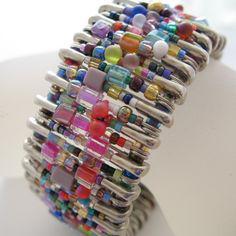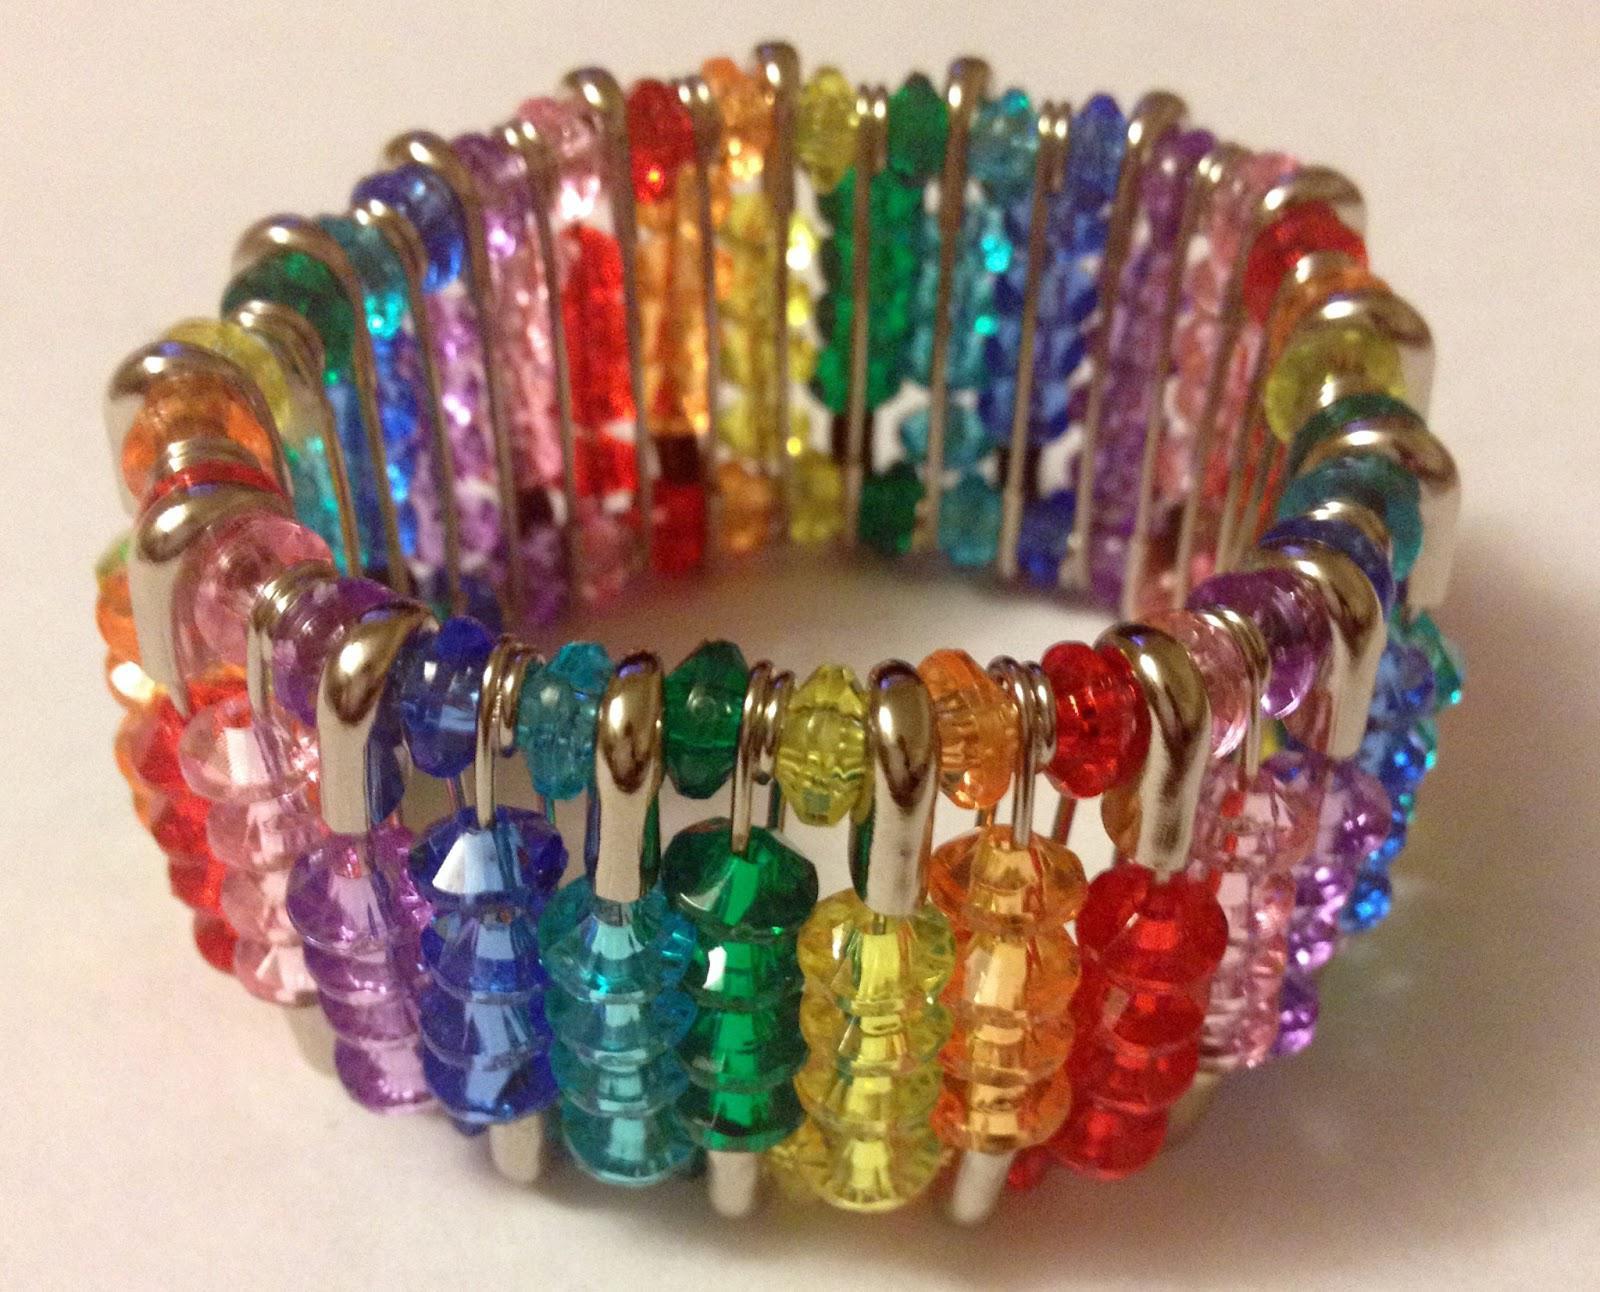The first image is the image on the left, the second image is the image on the right. For the images shown, is this caption "there is an arm in the image on the right." true? Answer yes or no. No. The first image is the image on the left, the second image is the image on the right. Considering the images on both sides, is "In the right image, the bracelet is shown on a wrist." valid? Answer yes or no. No. 